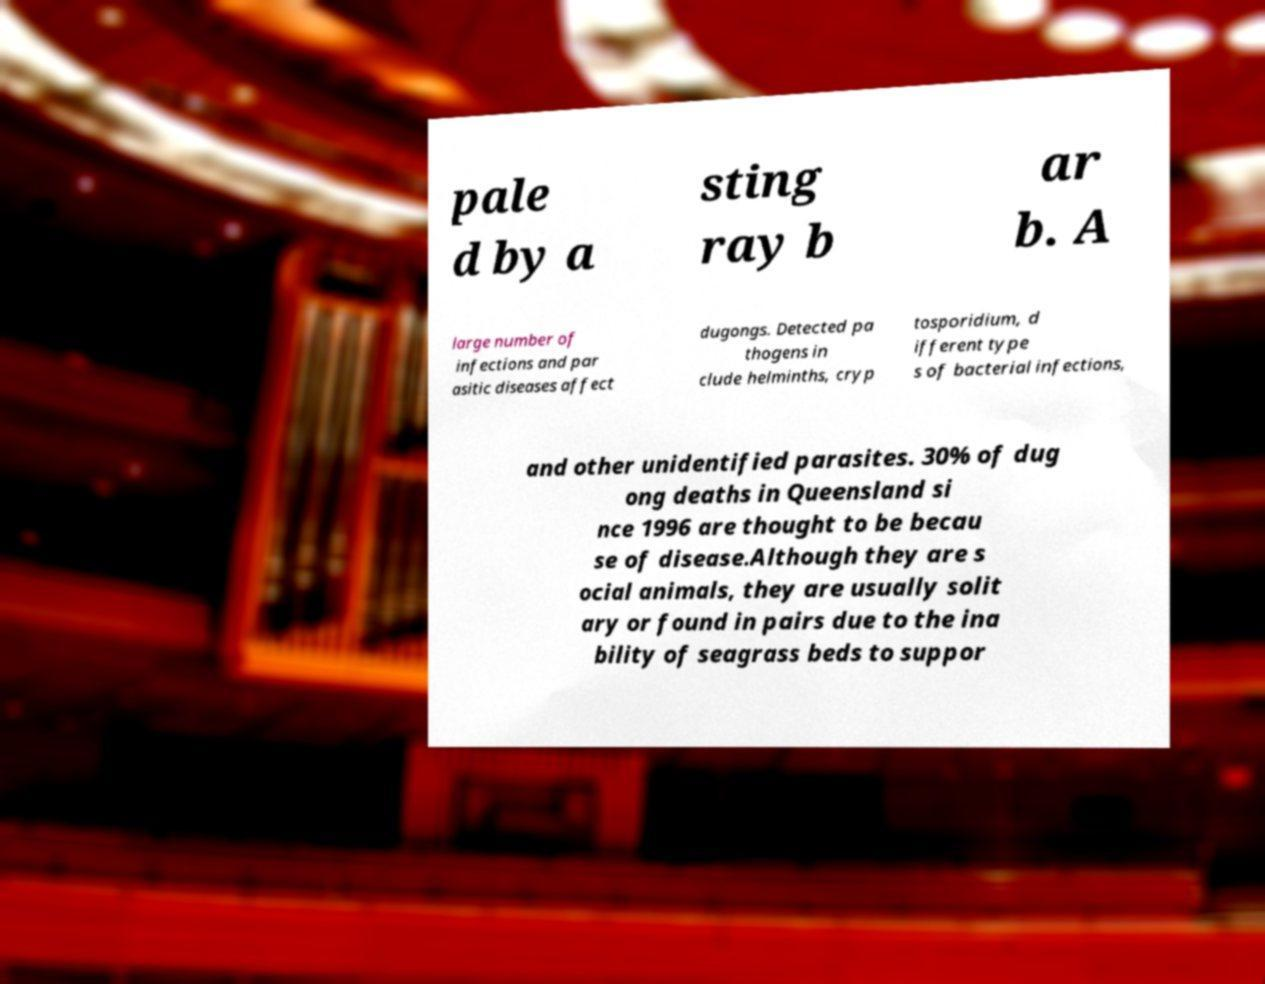There's text embedded in this image that I need extracted. Can you transcribe it verbatim? pale d by a sting ray b ar b. A large number of infections and par asitic diseases affect dugongs. Detected pa thogens in clude helminths, cryp tosporidium, d ifferent type s of bacterial infections, and other unidentified parasites. 30% of dug ong deaths in Queensland si nce 1996 are thought to be becau se of disease.Although they are s ocial animals, they are usually solit ary or found in pairs due to the ina bility of seagrass beds to suppor 